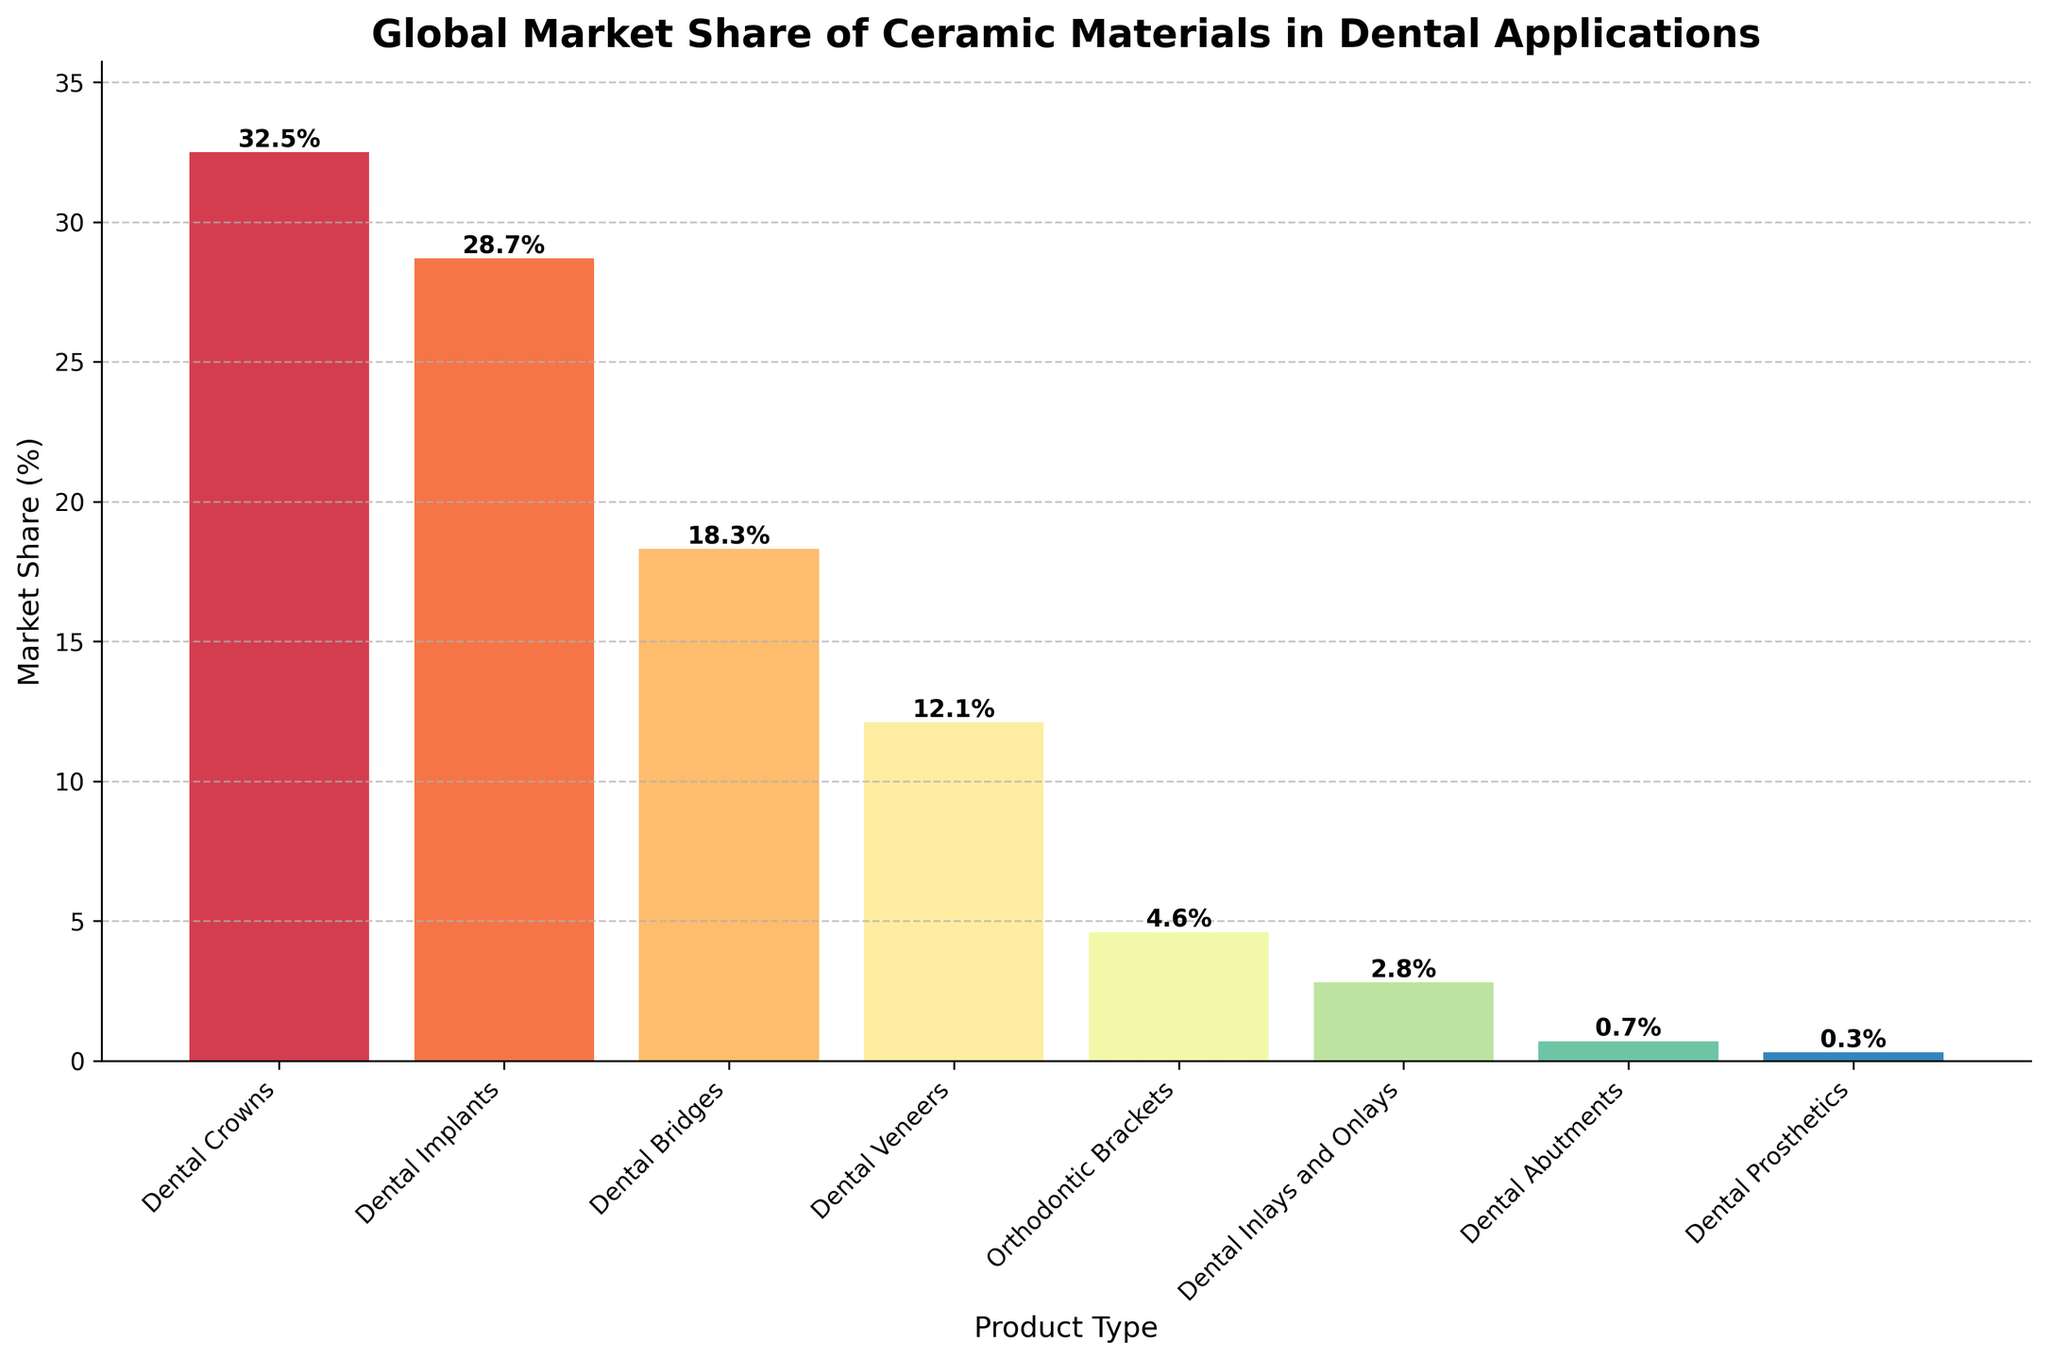What product type has the highest market share? By observing the height of the bars, the one with the highest height represents the product type with the highest market share. 'Dental Crowns' has the highest bar.
Answer: Dental Crowns Which product type has a lower market share, 'Dental Implants' or 'Dental Bridges'? Comparing the heights of the bars for 'Dental Implants' and 'Dental Bridges', the bar for 'Dental Bridges' is shorter.
Answer: Dental Bridges What is the combined market share of 'Dental Crowns' and 'Dental Implants'? The market share for 'Dental Crowns' is 32.5% and for 'Dental Implants' is 28.7%. Adding these together, 32.5% + 28.7% = 61.2%.
Answer: 61.2% What is the difference between the market share of 'Dental Veneers' and 'Orthodontic Brackets'? The market share for 'Dental Veneers' is 12.1% and for 'Orthodontic Brackets' is 4.6%. Subtracting these, 12.1% - 4.6% = 7.5%.
Answer: 7.5% Rank the product types from highest to lowest market share. Listed in descending order of market share: 32.5% (Dental Crowns), 28.7% (Dental Implants), 18.3% (Dental Bridges), 12.1% (Dental Veneers), 4.6% (Orthodontic Brackets), 2.8% (Dental Inlays and Onlays), 0.7% (Dental Abutments), 0.3% (Dental Prosthetics).
Answer: Dental Crowns, Dental Implants, Dental Bridges, Dental Veneers, Orthodontic Brackets, Dental Inlays and Onlays, Dental Abutments, Dental Prosthetics Which product type holds just above 12% of the market share? By looking at the height of the bars, 'Dental Veneers' holds just above 12%.
Answer: Dental Veneers Is the market share of 'Dental Crowns' larger than the sum of 'Dental Prosthetics', 'Dental Abutments', and 'Dental Inlays and Onlays'? The market share of 'Dental Crowns' is 32.5%. Summing the market shares of 'Dental Prosthetics' (0.3%), 'Dental Abutments' (0.7%), and 'Dental Inlays and Onlays' (2.8%) gives 0.3% + 0.7% + 2.8% = 3.8%. 32.5% is larger than 3.8%.
Answer: Yes What percentage of the market share do product types with less than 5% hold in total? Summing market shares of product types less than 5%: 'Orthodontic Brackets' (4.6%), 'Dental Inlays and Onlays' (2.8%), 'Dental Abutments' (0.7%), 'Dental Prosthetics' (0.3%). Total is 4.6% + 2.8% + 0.7% + 0.3% = 8.4%.
Answer: 8.4% What is the average market share of all product types? To find the average, sum all market share percentages and divide by the number of product types. Total sum = 32.5% + 28.7% + 18.3% + 12.1% + 4.6% + 2.8% + 0.7% + 0.3% = 100%. There are 8 product types, so average is 100% / 8 = 12.5%.
Answer: 12.5% 